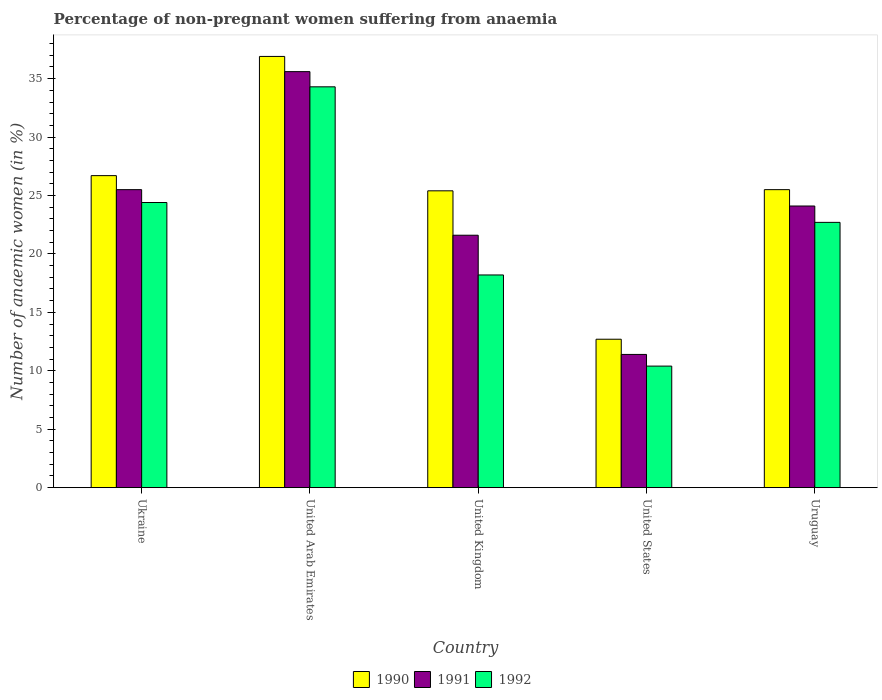How many different coloured bars are there?
Offer a very short reply. 3. How many groups of bars are there?
Offer a terse response. 5. Are the number of bars per tick equal to the number of legend labels?
Provide a succinct answer. Yes. How many bars are there on the 3rd tick from the left?
Your answer should be very brief. 3. How many bars are there on the 1st tick from the right?
Provide a succinct answer. 3. What is the label of the 1st group of bars from the left?
Ensure brevity in your answer.  Ukraine. In how many cases, is the number of bars for a given country not equal to the number of legend labels?
Offer a terse response. 0. What is the percentage of non-pregnant women suffering from anaemia in 1990 in United Kingdom?
Offer a terse response. 25.4. Across all countries, what is the maximum percentage of non-pregnant women suffering from anaemia in 1991?
Your answer should be very brief. 35.6. Across all countries, what is the minimum percentage of non-pregnant women suffering from anaemia in 1991?
Offer a terse response. 11.4. In which country was the percentage of non-pregnant women suffering from anaemia in 1992 maximum?
Keep it short and to the point. United Arab Emirates. In which country was the percentage of non-pregnant women suffering from anaemia in 1991 minimum?
Your response must be concise. United States. What is the total percentage of non-pregnant women suffering from anaemia in 1991 in the graph?
Give a very brief answer. 118.2. What is the difference between the percentage of non-pregnant women suffering from anaemia in 1990 in United Arab Emirates and that in Uruguay?
Give a very brief answer. 11.4. What is the difference between the percentage of non-pregnant women suffering from anaemia in 1992 in Ukraine and the percentage of non-pregnant women suffering from anaemia in 1990 in Uruguay?
Provide a short and direct response. -1.1. What is the average percentage of non-pregnant women suffering from anaemia in 1991 per country?
Your response must be concise. 23.64. What is the difference between the percentage of non-pregnant women suffering from anaemia of/in 1992 and percentage of non-pregnant women suffering from anaemia of/in 1990 in United Arab Emirates?
Your answer should be compact. -2.6. What is the ratio of the percentage of non-pregnant women suffering from anaemia in 1990 in Ukraine to that in Uruguay?
Offer a very short reply. 1.05. Is the percentage of non-pregnant women suffering from anaemia in 1990 in Ukraine less than that in United States?
Provide a succinct answer. No. Is the difference between the percentage of non-pregnant women suffering from anaemia in 1992 in Ukraine and United States greater than the difference between the percentage of non-pregnant women suffering from anaemia in 1990 in Ukraine and United States?
Your answer should be compact. No. What is the difference between the highest and the second highest percentage of non-pregnant women suffering from anaemia in 1990?
Keep it short and to the point. -1.2. What is the difference between the highest and the lowest percentage of non-pregnant women suffering from anaemia in 1990?
Your answer should be very brief. 24.2. Are all the bars in the graph horizontal?
Your answer should be compact. No. Are the values on the major ticks of Y-axis written in scientific E-notation?
Provide a succinct answer. No. Does the graph contain any zero values?
Provide a succinct answer. No. Where does the legend appear in the graph?
Ensure brevity in your answer.  Bottom center. What is the title of the graph?
Your answer should be very brief. Percentage of non-pregnant women suffering from anaemia. Does "1986" appear as one of the legend labels in the graph?
Give a very brief answer. No. What is the label or title of the Y-axis?
Offer a terse response. Number of anaemic women (in %). What is the Number of anaemic women (in %) of 1990 in Ukraine?
Your answer should be very brief. 26.7. What is the Number of anaemic women (in %) in 1992 in Ukraine?
Ensure brevity in your answer.  24.4. What is the Number of anaemic women (in %) of 1990 in United Arab Emirates?
Provide a succinct answer. 36.9. What is the Number of anaemic women (in %) of 1991 in United Arab Emirates?
Your answer should be very brief. 35.6. What is the Number of anaemic women (in %) of 1992 in United Arab Emirates?
Offer a very short reply. 34.3. What is the Number of anaemic women (in %) of 1990 in United Kingdom?
Your response must be concise. 25.4. What is the Number of anaemic women (in %) of 1991 in United Kingdom?
Your answer should be compact. 21.6. What is the Number of anaemic women (in %) of 1992 in United Kingdom?
Provide a short and direct response. 18.2. What is the Number of anaemic women (in %) of 1990 in United States?
Provide a succinct answer. 12.7. What is the Number of anaemic women (in %) of 1991 in United States?
Your response must be concise. 11.4. What is the Number of anaemic women (in %) in 1992 in United States?
Keep it short and to the point. 10.4. What is the Number of anaemic women (in %) in 1990 in Uruguay?
Give a very brief answer. 25.5. What is the Number of anaemic women (in %) of 1991 in Uruguay?
Provide a short and direct response. 24.1. What is the Number of anaemic women (in %) in 1992 in Uruguay?
Give a very brief answer. 22.7. Across all countries, what is the maximum Number of anaemic women (in %) of 1990?
Provide a short and direct response. 36.9. Across all countries, what is the maximum Number of anaemic women (in %) of 1991?
Provide a succinct answer. 35.6. Across all countries, what is the maximum Number of anaemic women (in %) in 1992?
Give a very brief answer. 34.3. Across all countries, what is the minimum Number of anaemic women (in %) in 1991?
Offer a terse response. 11.4. Across all countries, what is the minimum Number of anaemic women (in %) of 1992?
Make the answer very short. 10.4. What is the total Number of anaemic women (in %) of 1990 in the graph?
Give a very brief answer. 127.2. What is the total Number of anaemic women (in %) in 1991 in the graph?
Offer a terse response. 118.2. What is the total Number of anaemic women (in %) of 1992 in the graph?
Make the answer very short. 110. What is the difference between the Number of anaemic women (in %) of 1990 in Ukraine and that in United Kingdom?
Ensure brevity in your answer.  1.3. What is the difference between the Number of anaemic women (in %) in 1990 in Ukraine and that in United States?
Keep it short and to the point. 14. What is the difference between the Number of anaemic women (in %) of 1991 in Ukraine and that in Uruguay?
Keep it short and to the point. 1.4. What is the difference between the Number of anaemic women (in %) of 1991 in United Arab Emirates and that in United Kingdom?
Offer a terse response. 14. What is the difference between the Number of anaemic women (in %) of 1990 in United Arab Emirates and that in United States?
Your answer should be compact. 24.2. What is the difference between the Number of anaemic women (in %) in 1991 in United Arab Emirates and that in United States?
Your response must be concise. 24.2. What is the difference between the Number of anaemic women (in %) of 1992 in United Arab Emirates and that in United States?
Give a very brief answer. 23.9. What is the difference between the Number of anaemic women (in %) of 1990 in United Arab Emirates and that in Uruguay?
Keep it short and to the point. 11.4. What is the difference between the Number of anaemic women (in %) of 1990 in United Kingdom and that in United States?
Ensure brevity in your answer.  12.7. What is the difference between the Number of anaemic women (in %) in 1992 in United Kingdom and that in United States?
Provide a short and direct response. 7.8. What is the difference between the Number of anaemic women (in %) of 1990 in United Kingdom and that in Uruguay?
Your answer should be very brief. -0.1. What is the difference between the Number of anaemic women (in %) in 1991 in United Kingdom and that in Uruguay?
Your answer should be compact. -2.5. What is the difference between the Number of anaemic women (in %) of 1992 in United Kingdom and that in Uruguay?
Your response must be concise. -4.5. What is the difference between the Number of anaemic women (in %) in 1990 in United States and that in Uruguay?
Make the answer very short. -12.8. What is the difference between the Number of anaemic women (in %) of 1991 in United States and that in Uruguay?
Offer a very short reply. -12.7. What is the difference between the Number of anaemic women (in %) in 1992 in United States and that in Uruguay?
Keep it short and to the point. -12.3. What is the difference between the Number of anaemic women (in %) in 1990 in Ukraine and the Number of anaemic women (in %) in 1991 in United Arab Emirates?
Give a very brief answer. -8.9. What is the difference between the Number of anaemic women (in %) of 1990 in Ukraine and the Number of anaemic women (in %) of 1992 in United Arab Emirates?
Provide a succinct answer. -7.6. What is the difference between the Number of anaemic women (in %) in 1991 in Ukraine and the Number of anaemic women (in %) in 1992 in United Arab Emirates?
Provide a succinct answer. -8.8. What is the difference between the Number of anaemic women (in %) of 1990 in Ukraine and the Number of anaemic women (in %) of 1991 in United Kingdom?
Your answer should be compact. 5.1. What is the difference between the Number of anaemic women (in %) in 1990 in Ukraine and the Number of anaemic women (in %) in 1992 in United Kingdom?
Make the answer very short. 8.5. What is the difference between the Number of anaemic women (in %) of 1991 in Ukraine and the Number of anaemic women (in %) of 1992 in United Kingdom?
Offer a terse response. 7.3. What is the difference between the Number of anaemic women (in %) of 1990 in Ukraine and the Number of anaemic women (in %) of 1991 in United States?
Provide a short and direct response. 15.3. What is the difference between the Number of anaemic women (in %) in 1990 in Ukraine and the Number of anaemic women (in %) in 1992 in United States?
Offer a very short reply. 16.3. What is the difference between the Number of anaemic women (in %) of 1990 in Ukraine and the Number of anaemic women (in %) of 1991 in Uruguay?
Offer a very short reply. 2.6. What is the difference between the Number of anaemic women (in %) of 1990 in Ukraine and the Number of anaemic women (in %) of 1992 in Uruguay?
Provide a short and direct response. 4. What is the difference between the Number of anaemic women (in %) in 1990 in United Arab Emirates and the Number of anaemic women (in %) in 1991 in United Kingdom?
Your answer should be very brief. 15.3. What is the difference between the Number of anaemic women (in %) of 1990 in United Arab Emirates and the Number of anaemic women (in %) of 1992 in United Kingdom?
Your answer should be very brief. 18.7. What is the difference between the Number of anaemic women (in %) in 1991 in United Arab Emirates and the Number of anaemic women (in %) in 1992 in United Kingdom?
Give a very brief answer. 17.4. What is the difference between the Number of anaemic women (in %) of 1990 in United Arab Emirates and the Number of anaemic women (in %) of 1992 in United States?
Give a very brief answer. 26.5. What is the difference between the Number of anaemic women (in %) of 1991 in United Arab Emirates and the Number of anaemic women (in %) of 1992 in United States?
Give a very brief answer. 25.2. What is the difference between the Number of anaemic women (in %) in 1990 in United Arab Emirates and the Number of anaemic women (in %) in 1992 in Uruguay?
Give a very brief answer. 14.2. What is the difference between the Number of anaemic women (in %) of 1991 in United Arab Emirates and the Number of anaemic women (in %) of 1992 in Uruguay?
Provide a short and direct response. 12.9. What is the difference between the Number of anaemic women (in %) in 1990 in United Kingdom and the Number of anaemic women (in %) in 1992 in United States?
Provide a short and direct response. 15. What is the difference between the Number of anaemic women (in %) in 1990 in United States and the Number of anaemic women (in %) in 1991 in Uruguay?
Keep it short and to the point. -11.4. What is the difference between the Number of anaemic women (in %) of 1990 in United States and the Number of anaemic women (in %) of 1992 in Uruguay?
Keep it short and to the point. -10. What is the average Number of anaemic women (in %) of 1990 per country?
Provide a short and direct response. 25.44. What is the average Number of anaemic women (in %) of 1991 per country?
Offer a very short reply. 23.64. What is the difference between the Number of anaemic women (in %) of 1990 and Number of anaemic women (in %) of 1991 in Ukraine?
Your response must be concise. 1.2. What is the difference between the Number of anaemic women (in %) of 1991 and Number of anaemic women (in %) of 1992 in United Arab Emirates?
Offer a very short reply. 1.3. What is the difference between the Number of anaemic women (in %) in 1990 and Number of anaemic women (in %) in 1991 in United Kingdom?
Your response must be concise. 3.8. What is the difference between the Number of anaemic women (in %) of 1990 and Number of anaemic women (in %) of 1992 in United Kingdom?
Provide a short and direct response. 7.2. What is the difference between the Number of anaemic women (in %) in 1991 and Number of anaemic women (in %) in 1992 in United Kingdom?
Make the answer very short. 3.4. What is the difference between the Number of anaemic women (in %) in 1990 and Number of anaemic women (in %) in 1992 in United States?
Your answer should be compact. 2.3. What is the difference between the Number of anaemic women (in %) in 1991 and Number of anaemic women (in %) in 1992 in United States?
Your answer should be very brief. 1. What is the difference between the Number of anaemic women (in %) in 1990 and Number of anaemic women (in %) in 1991 in Uruguay?
Provide a short and direct response. 1.4. What is the difference between the Number of anaemic women (in %) of 1991 and Number of anaemic women (in %) of 1992 in Uruguay?
Give a very brief answer. 1.4. What is the ratio of the Number of anaemic women (in %) in 1990 in Ukraine to that in United Arab Emirates?
Ensure brevity in your answer.  0.72. What is the ratio of the Number of anaemic women (in %) of 1991 in Ukraine to that in United Arab Emirates?
Provide a succinct answer. 0.72. What is the ratio of the Number of anaemic women (in %) in 1992 in Ukraine to that in United Arab Emirates?
Provide a short and direct response. 0.71. What is the ratio of the Number of anaemic women (in %) of 1990 in Ukraine to that in United Kingdom?
Ensure brevity in your answer.  1.05. What is the ratio of the Number of anaemic women (in %) in 1991 in Ukraine to that in United Kingdom?
Give a very brief answer. 1.18. What is the ratio of the Number of anaemic women (in %) in 1992 in Ukraine to that in United Kingdom?
Make the answer very short. 1.34. What is the ratio of the Number of anaemic women (in %) in 1990 in Ukraine to that in United States?
Your answer should be very brief. 2.1. What is the ratio of the Number of anaemic women (in %) of 1991 in Ukraine to that in United States?
Give a very brief answer. 2.24. What is the ratio of the Number of anaemic women (in %) of 1992 in Ukraine to that in United States?
Offer a very short reply. 2.35. What is the ratio of the Number of anaemic women (in %) of 1990 in Ukraine to that in Uruguay?
Offer a terse response. 1.05. What is the ratio of the Number of anaemic women (in %) in 1991 in Ukraine to that in Uruguay?
Your response must be concise. 1.06. What is the ratio of the Number of anaemic women (in %) in 1992 in Ukraine to that in Uruguay?
Offer a very short reply. 1.07. What is the ratio of the Number of anaemic women (in %) of 1990 in United Arab Emirates to that in United Kingdom?
Your answer should be very brief. 1.45. What is the ratio of the Number of anaemic women (in %) of 1991 in United Arab Emirates to that in United Kingdom?
Provide a succinct answer. 1.65. What is the ratio of the Number of anaemic women (in %) in 1992 in United Arab Emirates to that in United Kingdom?
Ensure brevity in your answer.  1.88. What is the ratio of the Number of anaemic women (in %) of 1990 in United Arab Emirates to that in United States?
Provide a short and direct response. 2.91. What is the ratio of the Number of anaemic women (in %) of 1991 in United Arab Emirates to that in United States?
Make the answer very short. 3.12. What is the ratio of the Number of anaemic women (in %) of 1992 in United Arab Emirates to that in United States?
Your response must be concise. 3.3. What is the ratio of the Number of anaemic women (in %) in 1990 in United Arab Emirates to that in Uruguay?
Your response must be concise. 1.45. What is the ratio of the Number of anaemic women (in %) in 1991 in United Arab Emirates to that in Uruguay?
Offer a terse response. 1.48. What is the ratio of the Number of anaemic women (in %) in 1992 in United Arab Emirates to that in Uruguay?
Your answer should be compact. 1.51. What is the ratio of the Number of anaemic women (in %) of 1990 in United Kingdom to that in United States?
Your answer should be very brief. 2. What is the ratio of the Number of anaemic women (in %) in 1991 in United Kingdom to that in United States?
Ensure brevity in your answer.  1.89. What is the ratio of the Number of anaemic women (in %) in 1992 in United Kingdom to that in United States?
Your answer should be very brief. 1.75. What is the ratio of the Number of anaemic women (in %) in 1991 in United Kingdom to that in Uruguay?
Keep it short and to the point. 0.9. What is the ratio of the Number of anaemic women (in %) of 1992 in United Kingdom to that in Uruguay?
Provide a succinct answer. 0.8. What is the ratio of the Number of anaemic women (in %) of 1990 in United States to that in Uruguay?
Offer a terse response. 0.5. What is the ratio of the Number of anaemic women (in %) in 1991 in United States to that in Uruguay?
Give a very brief answer. 0.47. What is the ratio of the Number of anaemic women (in %) in 1992 in United States to that in Uruguay?
Keep it short and to the point. 0.46. What is the difference between the highest and the second highest Number of anaemic women (in %) of 1991?
Provide a succinct answer. 10.1. What is the difference between the highest and the second highest Number of anaemic women (in %) in 1992?
Make the answer very short. 9.9. What is the difference between the highest and the lowest Number of anaemic women (in %) of 1990?
Offer a very short reply. 24.2. What is the difference between the highest and the lowest Number of anaemic women (in %) in 1991?
Your response must be concise. 24.2. What is the difference between the highest and the lowest Number of anaemic women (in %) of 1992?
Your answer should be very brief. 23.9. 